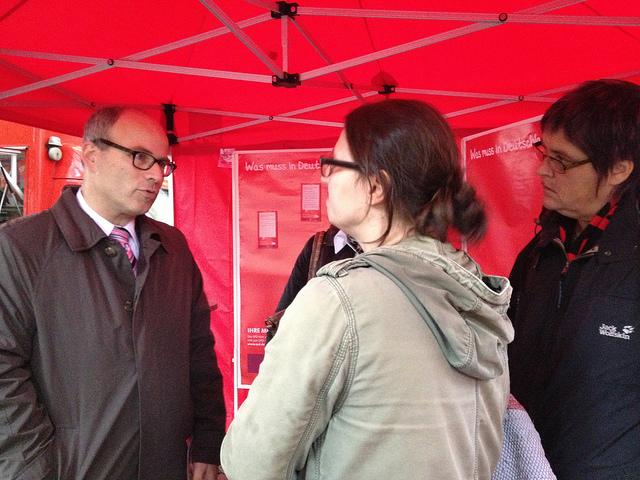How many glasses do you see?
Write a very short answer. 3. What kind of materials is it that makes up this red tent?
Concise answer only. Plastic. Are they talking?
Short answer required. Yes. 